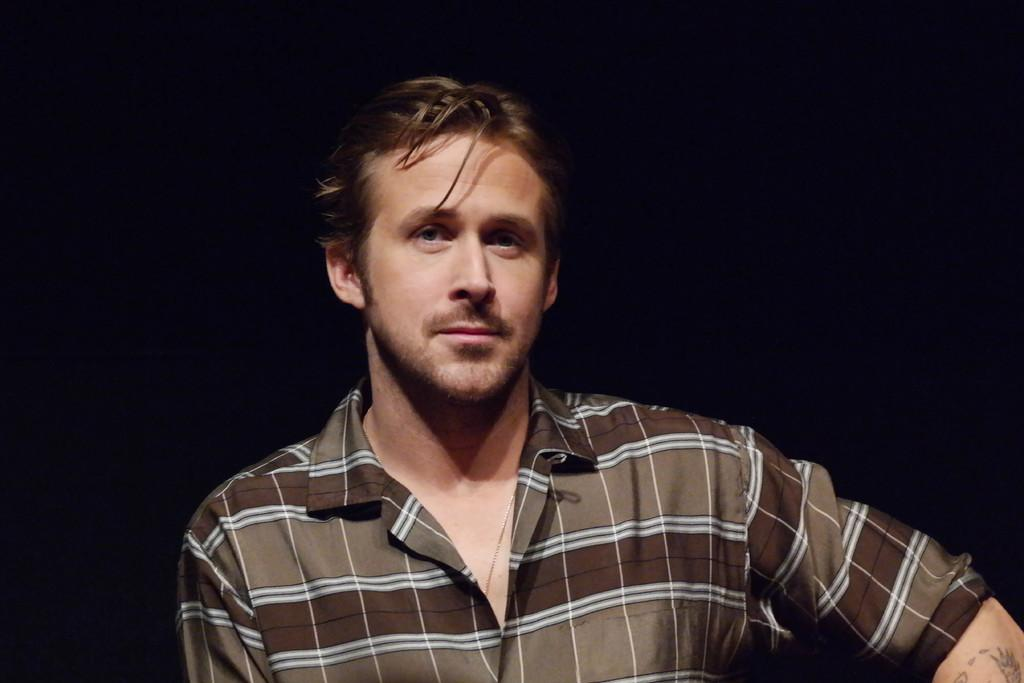Who is the main subject in the image? There is a man in the center of the image. What type of ant can be seen interacting with the man in the image? There is no ant present in the image; it only features a man. What is the purpose of the meeting that the man is attending in the image? There is no meeting depicted in the image, as it only shows a man in the center. 